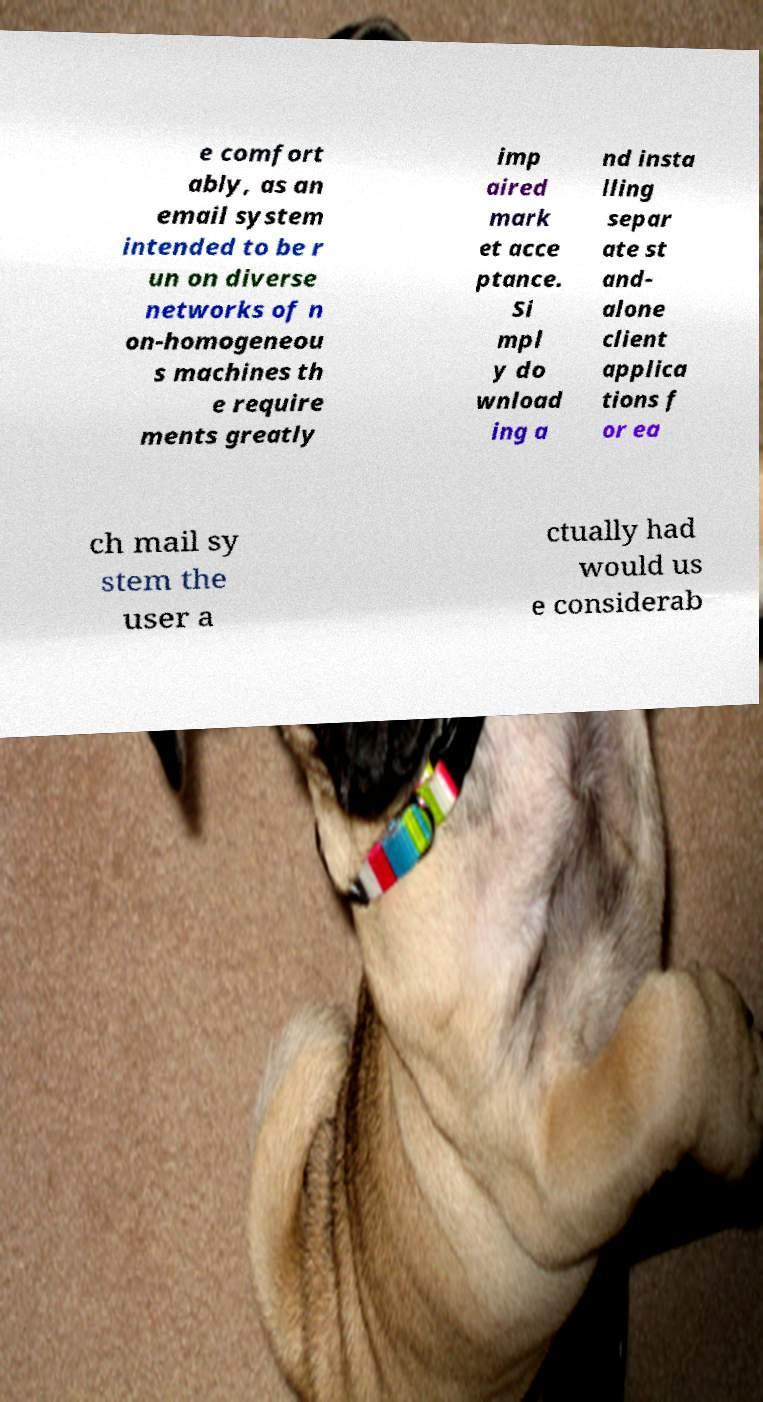Could you assist in decoding the text presented in this image and type it out clearly? e comfort ably, as an email system intended to be r un on diverse networks of n on-homogeneou s machines th e require ments greatly imp aired mark et acce ptance. Si mpl y do wnload ing a nd insta lling separ ate st and- alone client applica tions f or ea ch mail sy stem the user a ctually had would us e considerab 